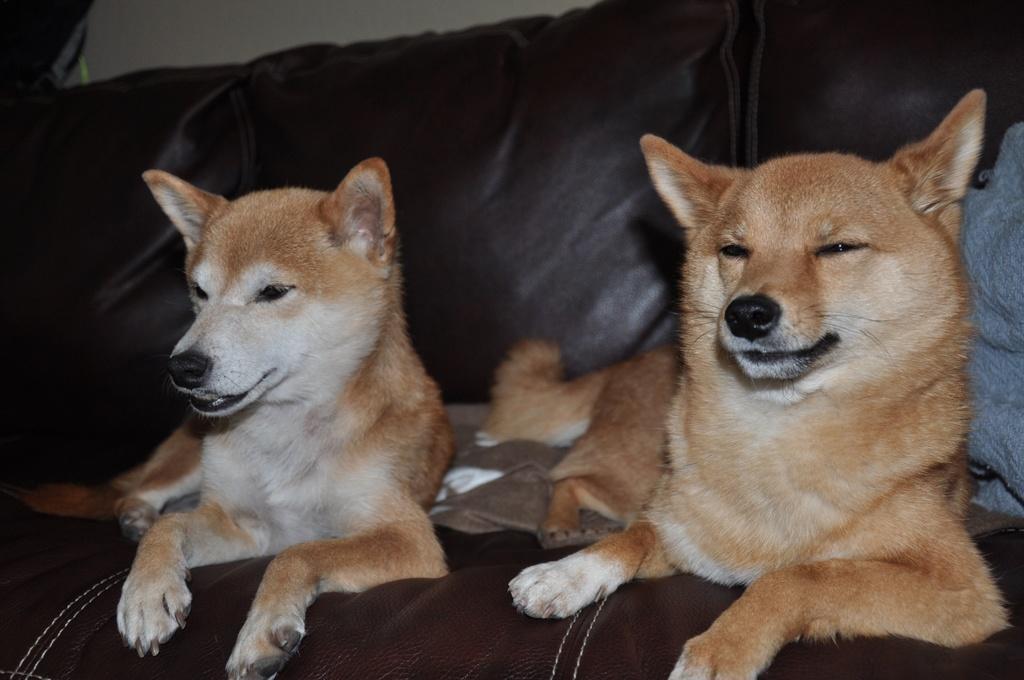Please provide a concise description of this image. In this image, we can see some dogs on the sofa. We can also see some cloth on the right. We can see the wall. 